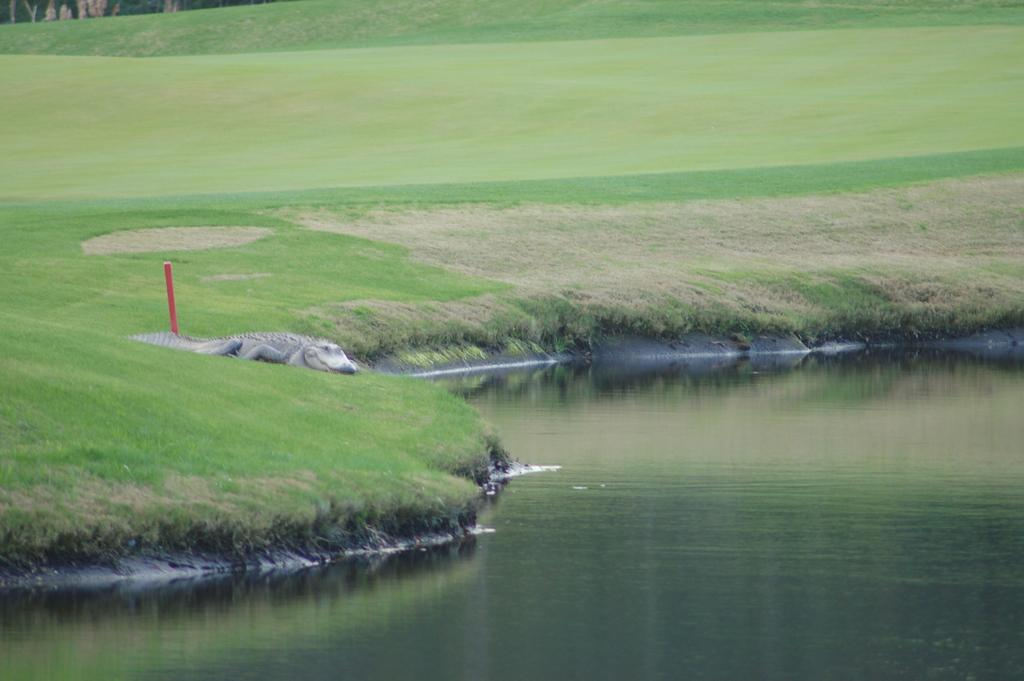What can be seen in the bottom right side of the image? There is water in the bottom right side of the image. What is the main subject in the middle of the image? There is a crocodile in the middle of the image. What type of vegetation is visible behind the crocodile? There is grass behind the crocodile. Can you see a goose swimming in the water with the crocodile? There is no goose present in the image; only a crocodile and water are visible. Is there any ice visible in the image? There is no ice present in the image. 